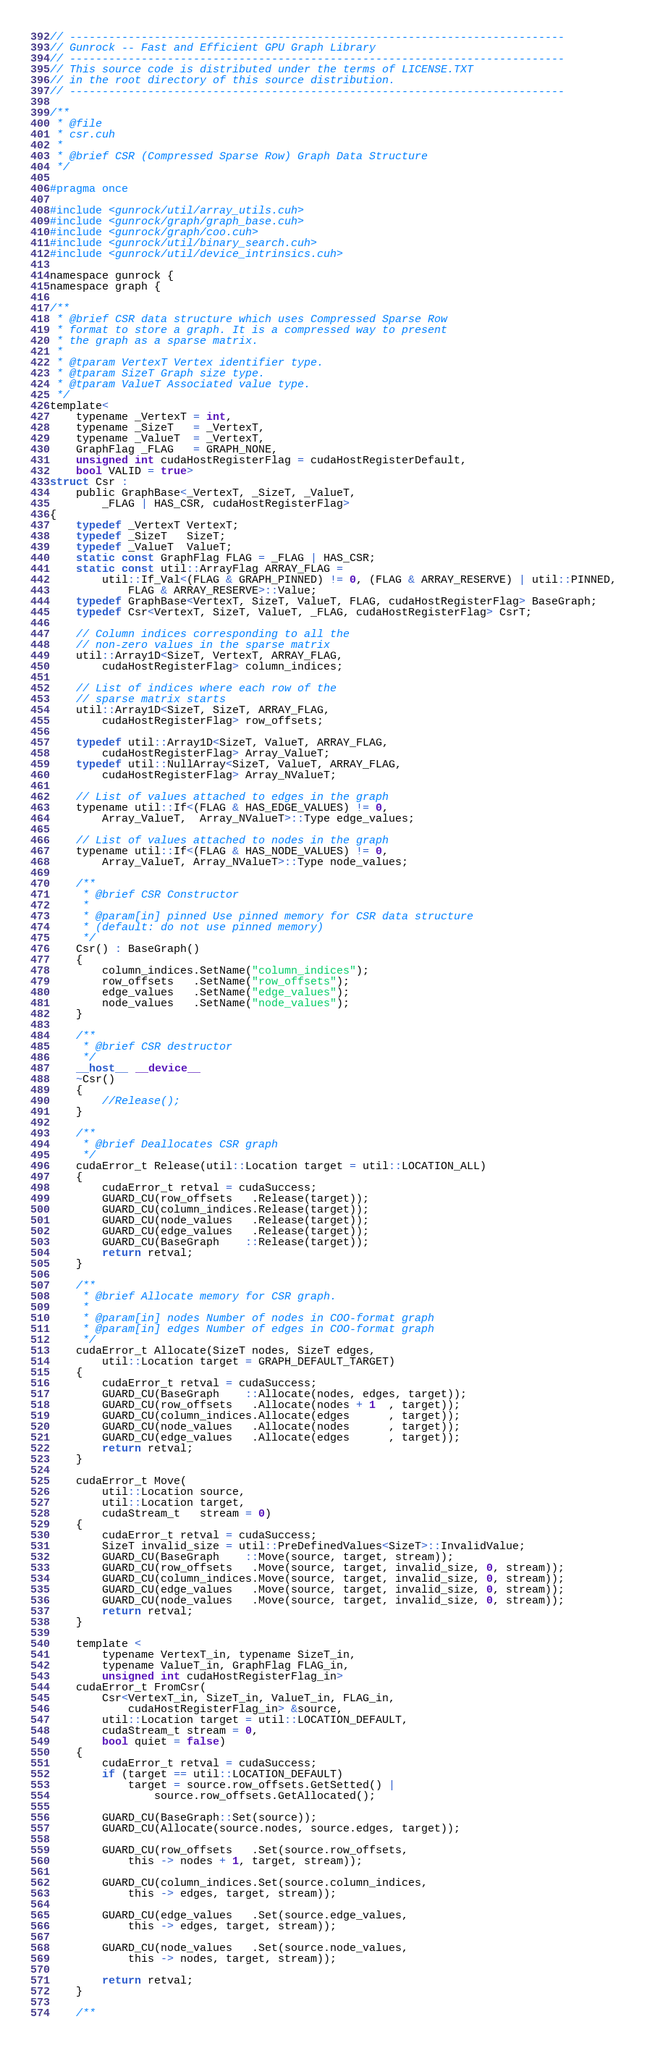Convert code to text. <code><loc_0><loc_0><loc_500><loc_500><_Cuda_>// ----------------------------------------------------------------------------
// Gunrock -- Fast and Efficient GPU Graph Library
// ----------------------------------------------------------------------------
// This source code is distributed under the terms of LICENSE.TXT
// in the root directory of this source distribution.
// ----------------------------------------------------------------------------

/**
 * @file
 * csr.cuh
 *
 * @brief CSR (Compressed Sparse Row) Graph Data Structure
 */

#pragma once

#include <gunrock/util/array_utils.cuh>
#include <gunrock/graph/graph_base.cuh>
#include <gunrock/graph/coo.cuh>
#include <gunrock/util/binary_search.cuh>
#include <gunrock/util/device_intrinsics.cuh>

namespace gunrock {
namespace graph {

/**
 * @brief CSR data structure which uses Compressed Sparse Row
 * format to store a graph. It is a compressed way to present
 * the graph as a sparse matrix.
 *
 * @tparam VertexT Vertex identifier type.
 * @tparam SizeT Graph size type.
 * @tparam ValueT Associated value type.
 */
template<
    typename _VertexT = int,
    typename _SizeT   = _VertexT,
    typename _ValueT  = _VertexT,
    GraphFlag _FLAG   = GRAPH_NONE,
    unsigned int cudaHostRegisterFlag = cudaHostRegisterDefault,
    bool VALID = true>
struct Csr :
    public GraphBase<_VertexT, _SizeT, _ValueT,
        _FLAG | HAS_CSR, cudaHostRegisterFlag>
{
    typedef _VertexT VertexT;
    typedef _SizeT   SizeT;
    typedef _ValueT  ValueT;
    static const GraphFlag FLAG = _FLAG | HAS_CSR;
    static const util::ArrayFlag ARRAY_FLAG =
        util::If_Val<(FLAG & GRAPH_PINNED) != 0, (FLAG & ARRAY_RESERVE) | util::PINNED,
            FLAG & ARRAY_RESERVE>::Value;
    typedef GraphBase<VertexT, SizeT, ValueT, FLAG, cudaHostRegisterFlag> BaseGraph;
    typedef Csr<VertexT, SizeT, ValueT, _FLAG, cudaHostRegisterFlag> CsrT;

    // Column indices corresponding to all the
    // non-zero values in the sparse matrix
    util::Array1D<SizeT, VertexT, ARRAY_FLAG,
        cudaHostRegisterFlag> column_indices;

    // List of indices where each row of the
    // sparse matrix starts
    util::Array1D<SizeT, SizeT, ARRAY_FLAG,
        cudaHostRegisterFlag> row_offsets;

    typedef util::Array1D<SizeT, ValueT, ARRAY_FLAG,
        cudaHostRegisterFlag> Array_ValueT;
    typedef util::NullArray<SizeT, ValueT, ARRAY_FLAG,
        cudaHostRegisterFlag> Array_NValueT;

    // List of values attached to edges in the graph
    typename util::If<(FLAG & HAS_EDGE_VALUES) != 0,
        Array_ValueT,  Array_NValueT>::Type edge_values;

    // List of values attached to nodes in the graph
    typename util::If<(FLAG & HAS_NODE_VALUES) != 0,
        Array_ValueT, Array_NValueT>::Type node_values;

    /**
     * @brief CSR Constructor
     *
     * @param[in] pinned Use pinned memory for CSR data structure
     * (default: do not use pinned memory)
     */
    Csr() : BaseGraph()
    {
        column_indices.SetName("column_indices");
        row_offsets   .SetName("row_offsets");
        edge_values   .SetName("edge_values");
        node_values   .SetName("node_values");
    }

    /**
     * @brief CSR destructor
     */
    __host__ __device__
    ~Csr()
    {
        //Release();
    }

    /**
     * @brief Deallocates CSR graph
     */
    cudaError_t Release(util::Location target = util::LOCATION_ALL)
    {
        cudaError_t retval = cudaSuccess;
        GUARD_CU(row_offsets   .Release(target));
        GUARD_CU(column_indices.Release(target));
        GUARD_CU(node_values   .Release(target));
        GUARD_CU(edge_values   .Release(target));
        GUARD_CU(BaseGraph    ::Release(target));
        return retval;
    }

    /**
     * @brief Allocate memory for CSR graph.
     *
     * @param[in] nodes Number of nodes in COO-format graph
     * @param[in] edges Number of edges in COO-format graph
     */
    cudaError_t Allocate(SizeT nodes, SizeT edges,
        util::Location target = GRAPH_DEFAULT_TARGET)
    {
        cudaError_t retval = cudaSuccess;
        GUARD_CU(BaseGraph    ::Allocate(nodes, edges, target));
        GUARD_CU(row_offsets   .Allocate(nodes + 1  , target));
        GUARD_CU(column_indices.Allocate(edges      , target));
        GUARD_CU(node_values   .Allocate(nodes      , target));
        GUARD_CU(edge_values   .Allocate(edges      , target));
        return retval;
    }

    cudaError_t Move(
        util::Location source,
        util::Location target,
        cudaStream_t   stream = 0)
    {
        cudaError_t retval = cudaSuccess;
        SizeT invalid_size = util::PreDefinedValues<SizeT>::InvalidValue;
        GUARD_CU(BaseGraph    ::Move(source, target, stream));
        GUARD_CU(row_offsets   .Move(source, target, invalid_size, 0, stream));
        GUARD_CU(column_indices.Move(source, target, invalid_size, 0, stream));
        GUARD_CU(edge_values   .Move(source, target, invalid_size, 0, stream));
        GUARD_CU(node_values   .Move(source, target, invalid_size, 0, stream));
        return retval;
    }

    template <
        typename VertexT_in, typename SizeT_in,
        typename ValueT_in, GraphFlag FLAG_in,
        unsigned int cudaHostRegisterFlag_in>
    cudaError_t FromCsr(
        Csr<VertexT_in, SizeT_in, ValueT_in, FLAG_in,
            cudaHostRegisterFlag_in> &source,
        util::Location target = util::LOCATION_DEFAULT,
        cudaStream_t stream = 0,
        bool quiet = false)
    {
        cudaError_t retval = cudaSuccess;
        if (target == util::LOCATION_DEFAULT)
            target = source.row_offsets.GetSetted() |
                source.row_offsets.GetAllocated();

        GUARD_CU(BaseGraph::Set(source));
        GUARD_CU(Allocate(source.nodes, source.edges, target));

        GUARD_CU(row_offsets   .Set(source.row_offsets,
            this -> nodes + 1, target, stream));

        GUARD_CU(column_indices.Set(source.column_indices,
            this -> edges, target, stream));

        GUARD_CU(edge_values   .Set(source.edge_values,
            this -> edges, target, stream));

        GUARD_CU(node_values   .Set(source.node_values,
            this -> nodes, target, stream));

        return retval;
    }

    /**</code> 